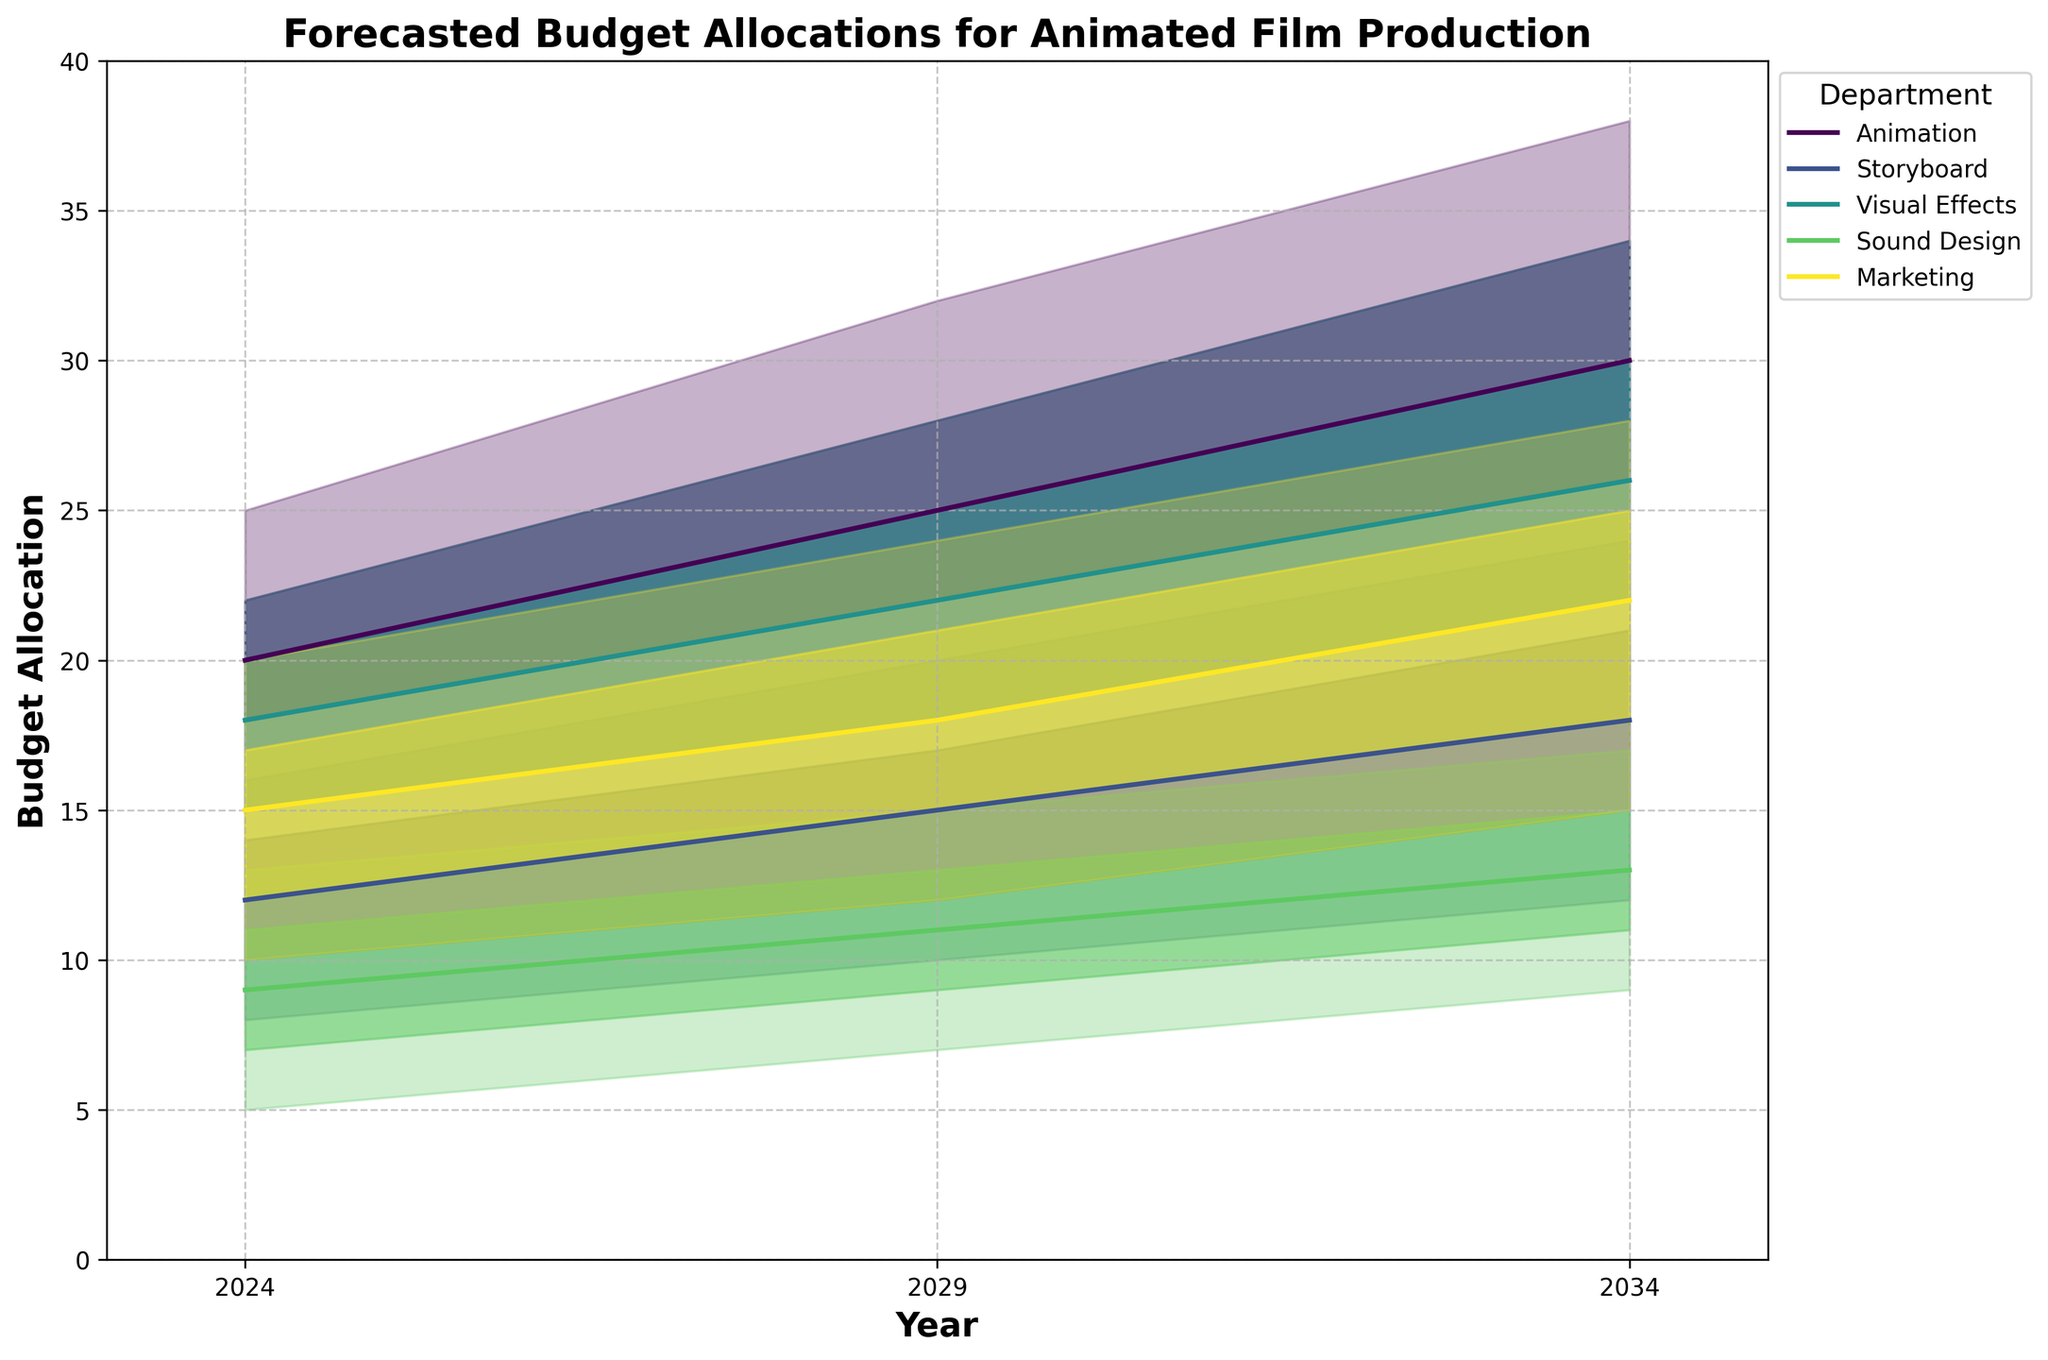What is the title of the plot? The title can be found at the top of the plot, indicating the main subject of the visualization.
Answer: Forecasted Budget Allocations for Animated Film Production What is the predicted median budget allocation for Animation in the year 2029? Find the year 2029 along the x-axis, then look at the P50 (median) value for the Animation department.
Answer: 25 Which department has the highest 90th percentile budget allocation in 2034? Check the P90 column for each department in the year 2034 and compare the values to determine the highest one.
Answer: Animation By how much is the 75th percentile budget allocation for Sound Design expected to increase from 2024 to 2029? Subtract the 75th percentile value for Sound Design in 2024 from the value in 2029.
Answer: 2 Which department sees the largest median budget allocation increase from 2024 to 2034? Calculate the difference in P50 values for each department between 2024 and 2034, and compare the differences to determine the largest one.
Answer: Animation In which year does Marketing have its lowest median budget allocation, and what is that value? Identify the P50 (median) values for Marketing across all the years and find the lowest value and its corresponding year.
Answer: 2024, 15 Compare the 25th percentile budget allocations for Storyboard and Visual Effects in the year 2029. Which one is higher? Look at the P25 values for both Storyboard and Visual Effects in the year 2029, and see which is greater.
Answer: Visual Effects How does the range of budget allocation (P10 to P90) for Animation change from 2024 to 2034? Calculate the difference between P90 and P10 for Animation for both the years 2024 and 2034, and compare them.
Answer: Increased from 10 to 16 What is the expected budget allocation range (P25 to P75) for Sound Design in 2034? Find the P25 and P75 values for Sound Design in 2034 and provide the range.
Answer: 11-15 Which department shows the most consistent budget allocation trend from 2024 to 2034, and on what basis do you refer 'consistent'? Evaluate the ranges between P10 to P90 and P25 to P75 for each department from 2024 to 2034 to determine which department has the least variation.
Answer: Storyboard 